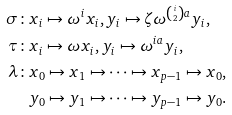<formula> <loc_0><loc_0><loc_500><loc_500>\sigma \colon & x _ { i } \mapsto \omega ^ { i } x _ { i } , y _ { i } \mapsto \zeta \omega ^ { { i \choose 2 } a } y _ { i } , \\ \tau \colon & x _ { i } \mapsto \omega x _ { i } , y _ { i } \mapsto \omega ^ { i a } y _ { i } , \\ \lambda \colon & x _ { 0 } \mapsto x _ { 1 } \mapsto \cdots \mapsto x _ { p - 1 } \mapsto x _ { 0 } , \\ & y _ { 0 } \mapsto y _ { 1 } \mapsto \cdots \mapsto y _ { p - 1 } \mapsto y _ { 0 } .</formula> 